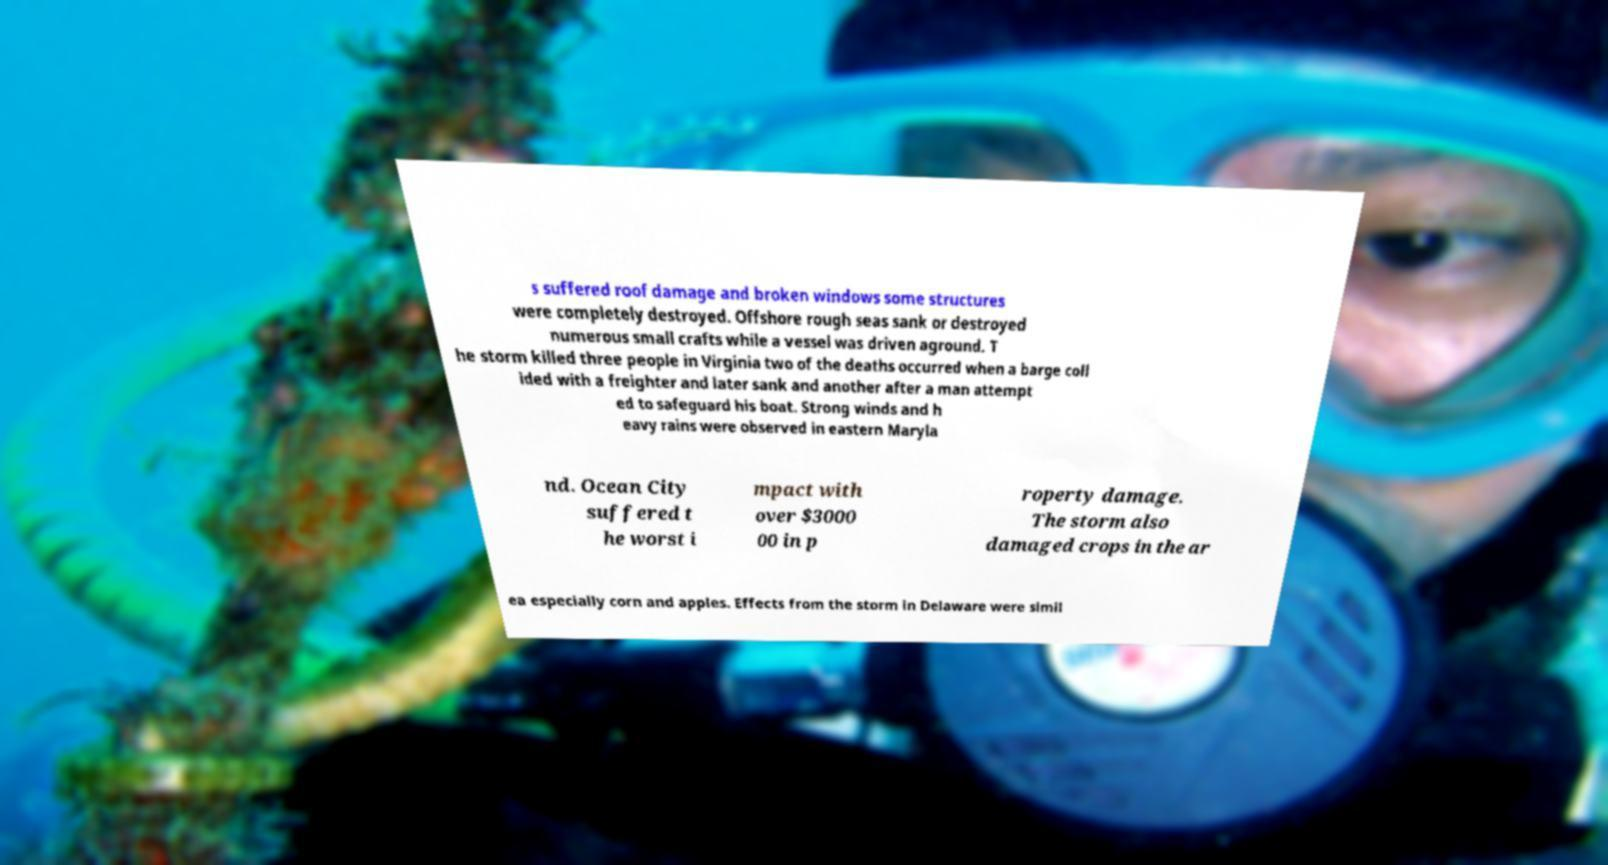Please read and relay the text visible in this image. What does it say? s suffered roof damage and broken windows some structures were completely destroyed. Offshore rough seas sank or destroyed numerous small crafts while a vessel was driven aground. T he storm killed three people in Virginia two of the deaths occurred when a barge coll ided with a freighter and later sank and another after a man attempt ed to safeguard his boat. Strong winds and h eavy rains were observed in eastern Maryla nd. Ocean City suffered t he worst i mpact with over $3000 00 in p roperty damage. The storm also damaged crops in the ar ea especially corn and apples. Effects from the storm in Delaware were simil 